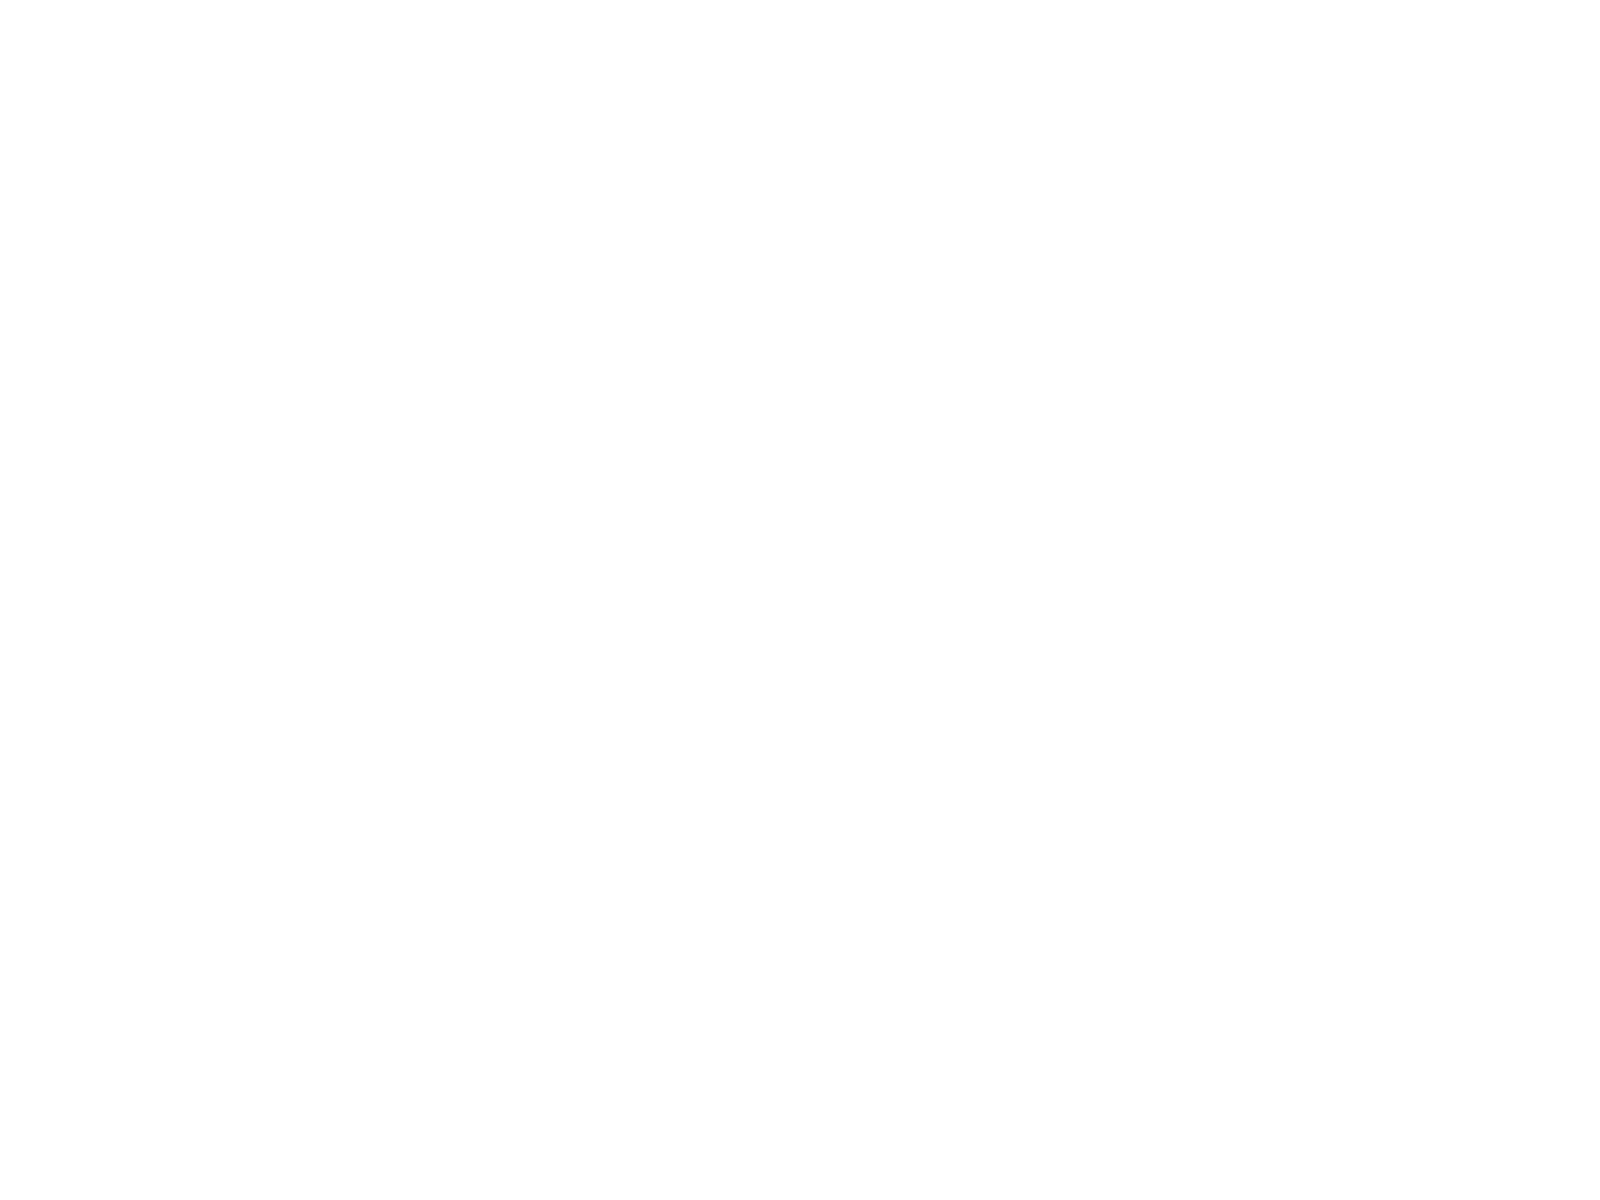Convert chart. <chart><loc_0><loc_0><loc_500><loc_500><pie_chart><fcel>Year Ended December 31<fcel>Interest expense<fcel>Interest income<fcel>Interest expense net<nl><fcel>76.29%<fcel>15.5%<fcel>0.3%<fcel>7.9%<nl></chart> 